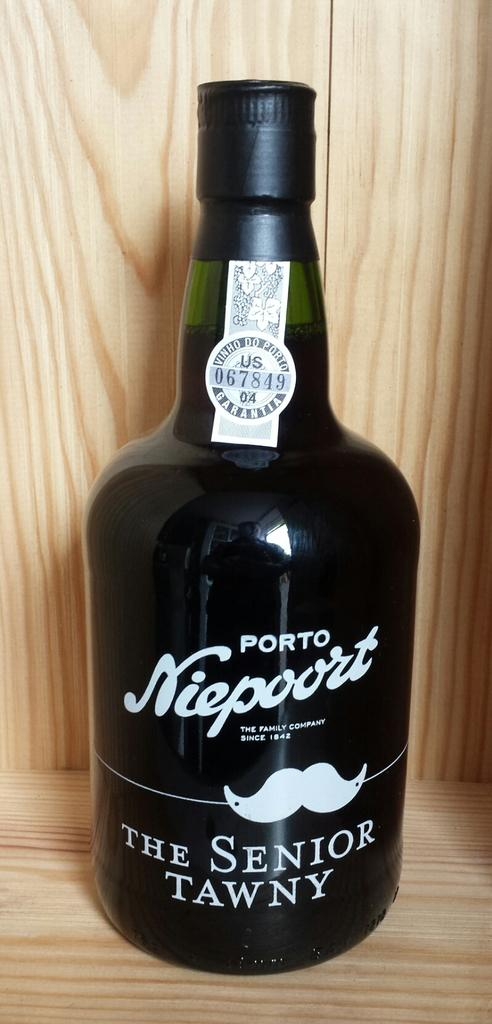<image>
Relay a brief, clear account of the picture shown. The bottle of Porto Niepoort has a picture of a mustache on it. 